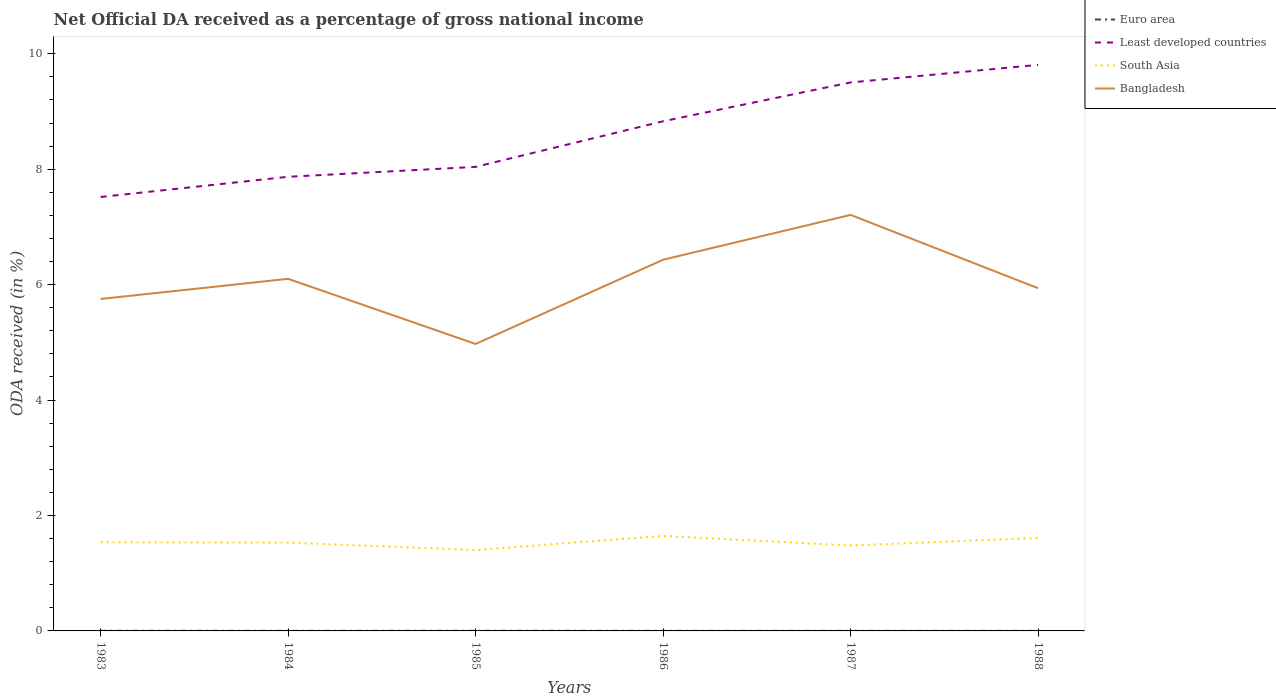How many different coloured lines are there?
Your answer should be very brief. 4. Across all years, what is the maximum net official DA received in Bangladesh?
Offer a very short reply. 4.97. What is the total net official DA received in South Asia in the graph?
Give a very brief answer. -0.07. What is the difference between the highest and the second highest net official DA received in Euro area?
Offer a terse response. 0. What is the difference between the highest and the lowest net official DA received in Bangladesh?
Make the answer very short. 3. Is the net official DA received in Bangladesh strictly greater than the net official DA received in Least developed countries over the years?
Your answer should be very brief. Yes. Are the values on the major ticks of Y-axis written in scientific E-notation?
Give a very brief answer. No. Does the graph contain grids?
Your answer should be very brief. No. Where does the legend appear in the graph?
Give a very brief answer. Top right. How many legend labels are there?
Offer a terse response. 4. How are the legend labels stacked?
Give a very brief answer. Vertical. What is the title of the graph?
Offer a very short reply. Net Official DA received as a percentage of gross national income. What is the label or title of the Y-axis?
Keep it short and to the point. ODA received (in %). What is the ODA received (in %) in Euro area in 1983?
Keep it short and to the point. 0. What is the ODA received (in %) of Least developed countries in 1983?
Your answer should be compact. 7.52. What is the ODA received (in %) of South Asia in 1983?
Make the answer very short. 1.54. What is the ODA received (in %) in Bangladesh in 1983?
Your answer should be compact. 5.75. What is the ODA received (in %) in Euro area in 1984?
Offer a terse response. 0. What is the ODA received (in %) in Least developed countries in 1984?
Make the answer very short. 7.87. What is the ODA received (in %) in South Asia in 1984?
Make the answer very short. 1.53. What is the ODA received (in %) in Bangladesh in 1984?
Provide a succinct answer. 6.1. What is the ODA received (in %) in Euro area in 1985?
Your response must be concise. 0. What is the ODA received (in %) in Least developed countries in 1985?
Keep it short and to the point. 8.04. What is the ODA received (in %) in South Asia in 1985?
Offer a terse response. 1.4. What is the ODA received (in %) of Bangladesh in 1985?
Give a very brief answer. 4.97. What is the ODA received (in %) in Euro area in 1986?
Provide a short and direct response. 0. What is the ODA received (in %) in Least developed countries in 1986?
Offer a very short reply. 8.83. What is the ODA received (in %) in South Asia in 1986?
Make the answer very short. 1.65. What is the ODA received (in %) in Bangladesh in 1986?
Your answer should be very brief. 6.43. What is the ODA received (in %) in Euro area in 1987?
Provide a short and direct response. 0. What is the ODA received (in %) in Least developed countries in 1987?
Provide a succinct answer. 9.5. What is the ODA received (in %) in South Asia in 1987?
Keep it short and to the point. 1.48. What is the ODA received (in %) of Bangladesh in 1987?
Ensure brevity in your answer.  7.21. What is the ODA received (in %) in Euro area in 1988?
Keep it short and to the point. 0. What is the ODA received (in %) of Least developed countries in 1988?
Ensure brevity in your answer.  9.81. What is the ODA received (in %) in South Asia in 1988?
Offer a terse response. 1.61. What is the ODA received (in %) of Bangladesh in 1988?
Keep it short and to the point. 5.94. Across all years, what is the maximum ODA received (in %) in Euro area?
Provide a succinct answer. 0. Across all years, what is the maximum ODA received (in %) of Least developed countries?
Provide a succinct answer. 9.81. Across all years, what is the maximum ODA received (in %) of South Asia?
Provide a succinct answer. 1.65. Across all years, what is the maximum ODA received (in %) in Bangladesh?
Provide a succinct answer. 7.21. Across all years, what is the minimum ODA received (in %) in Euro area?
Make the answer very short. 0. Across all years, what is the minimum ODA received (in %) of Least developed countries?
Your answer should be compact. 7.52. Across all years, what is the minimum ODA received (in %) in South Asia?
Your answer should be compact. 1.4. Across all years, what is the minimum ODA received (in %) in Bangladesh?
Keep it short and to the point. 4.97. What is the total ODA received (in %) of Euro area in the graph?
Offer a very short reply. 0.01. What is the total ODA received (in %) of Least developed countries in the graph?
Keep it short and to the point. 51.57. What is the total ODA received (in %) of South Asia in the graph?
Make the answer very short. 9.21. What is the total ODA received (in %) in Bangladesh in the graph?
Provide a short and direct response. 36.4. What is the difference between the ODA received (in %) in Euro area in 1983 and that in 1984?
Your answer should be compact. 0. What is the difference between the ODA received (in %) in Least developed countries in 1983 and that in 1984?
Your answer should be compact. -0.35. What is the difference between the ODA received (in %) in South Asia in 1983 and that in 1984?
Make the answer very short. 0.01. What is the difference between the ODA received (in %) of Bangladesh in 1983 and that in 1984?
Offer a very short reply. -0.35. What is the difference between the ODA received (in %) of Least developed countries in 1983 and that in 1985?
Offer a very short reply. -0.52. What is the difference between the ODA received (in %) in South Asia in 1983 and that in 1985?
Keep it short and to the point. 0.14. What is the difference between the ODA received (in %) of Bangladesh in 1983 and that in 1985?
Give a very brief answer. 0.78. What is the difference between the ODA received (in %) in Euro area in 1983 and that in 1986?
Ensure brevity in your answer.  0. What is the difference between the ODA received (in %) of Least developed countries in 1983 and that in 1986?
Ensure brevity in your answer.  -1.31. What is the difference between the ODA received (in %) of South Asia in 1983 and that in 1986?
Make the answer very short. -0.11. What is the difference between the ODA received (in %) in Bangladesh in 1983 and that in 1986?
Your answer should be compact. -0.68. What is the difference between the ODA received (in %) in Euro area in 1983 and that in 1987?
Ensure brevity in your answer.  0. What is the difference between the ODA received (in %) of Least developed countries in 1983 and that in 1987?
Your answer should be very brief. -1.99. What is the difference between the ODA received (in %) in South Asia in 1983 and that in 1987?
Offer a terse response. 0.06. What is the difference between the ODA received (in %) of Bangladesh in 1983 and that in 1987?
Offer a terse response. -1.46. What is the difference between the ODA received (in %) of Euro area in 1983 and that in 1988?
Your answer should be very brief. 0. What is the difference between the ODA received (in %) of Least developed countries in 1983 and that in 1988?
Make the answer very short. -2.29. What is the difference between the ODA received (in %) in South Asia in 1983 and that in 1988?
Offer a terse response. -0.07. What is the difference between the ODA received (in %) in Bangladesh in 1983 and that in 1988?
Offer a terse response. -0.19. What is the difference between the ODA received (in %) in Euro area in 1984 and that in 1985?
Your answer should be compact. -0. What is the difference between the ODA received (in %) of Least developed countries in 1984 and that in 1985?
Ensure brevity in your answer.  -0.17. What is the difference between the ODA received (in %) of South Asia in 1984 and that in 1985?
Provide a succinct answer. 0.13. What is the difference between the ODA received (in %) of Bangladesh in 1984 and that in 1985?
Your answer should be compact. 1.13. What is the difference between the ODA received (in %) of Euro area in 1984 and that in 1986?
Provide a succinct answer. -0. What is the difference between the ODA received (in %) in Least developed countries in 1984 and that in 1986?
Your answer should be compact. -0.96. What is the difference between the ODA received (in %) of South Asia in 1984 and that in 1986?
Give a very brief answer. -0.11. What is the difference between the ODA received (in %) of Bangladesh in 1984 and that in 1986?
Provide a short and direct response. -0.33. What is the difference between the ODA received (in %) in Least developed countries in 1984 and that in 1987?
Offer a terse response. -1.64. What is the difference between the ODA received (in %) in South Asia in 1984 and that in 1987?
Your response must be concise. 0.05. What is the difference between the ODA received (in %) in Bangladesh in 1984 and that in 1987?
Make the answer very short. -1.11. What is the difference between the ODA received (in %) of Least developed countries in 1984 and that in 1988?
Your response must be concise. -1.94. What is the difference between the ODA received (in %) of South Asia in 1984 and that in 1988?
Offer a terse response. -0.08. What is the difference between the ODA received (in %) of Bangladesh in 1984 and that in 1988?
Provide a short and direct response. 0.16. What is the difference between the ODA received (in %) in Euro area in 1985 and that in 1986?
Your response must be concise. 0. What is the difference between the ODA received (in %) of Least developed countries in 1985 and that in 1986?
Give a very brief answer. -0.79. What is the difference between the ODA received (in %) of South Asia in 1985 and that in 1986?
Offer a terse response. -0.24. What is the difference between the ODA received (in %) in Bangladesh in 1985 and that in 1986?
Make the answer very short. -1.46. What is the difference between the ODA received (in %) of Euro area in 1985 and that in 1987?
Your answer should be compact. 0. What is the difference between the ODA received (in %) of Least developed countries in 1985 and that in 1987?
Keep it short and to the point. -1.46. What is the difference between the ODA received (in %) of South Asia in 1985 and that in 1987?
Ensure brevity in your answer.  -0.08. What is the difference between the ODA received (in %) in Bangladesh in 1985 and that in 1987?
Keep it short and to the point. -2.24. What is the difference between the ODA received (in %) of Euro area in 1985 and that in 1988?
Your answer should be very brief. 0. What is the difference between the ODA received (in %) in Least developed countries in 1985 and that in 1988?
Keep it short and to the point. -1.77. What is the difference between the ODA received (in %) of South Asia in 1985 and that in 1988?
Offer a terse response. -0.21. What is the difference between the ODA received (in %) in Bangladesh in 1985 and that in 1988?
Offer a very short reply. -0.97. What is the difference between the ODA received (in %) in Least developed countries in 1986 and that in 1987?
Make the answer very short. -0.67. What is the difference between the ODA received (in %) in South Asia in 1986 and that in 1987?
Your answer should be very brief. 0.17. What is the difference between the ODA received (in %) in Bangladesh in 1986 and that in 1987?
Ensure brevity in your answer.  -0.78. What is the difference between the ODA received (in %) of Euro area in 1986 and that in 1988?
Ensure brevity in your answer.  0. What is the difference between the ODA received (in %) in Least developed countries in 1986 and that in 1988?
Give a very brief answer. -0.98. What is the difference between the ODA received (in %) of South Asia in 1986 and that in 1988?
Ensure brevity in your answer.  0.03. What is the difference between the ODA received (in %) of Bangladesh in 1986 and that in 1988?
Give a very brief answer. 0.49. What is the difference between the ODA received (in %) in Euro area in 1987 and that in 1988?
Give a very brief answer. 0. What is the difference between the ODA received (in %) in Least developed countries in 1987 and that in 1988?
Offer a very short reply. -0.3. What is the difference between the ODA received (in %) in South Asia in 1987 and that in 1988?
Your answer should be compact. -0.13. What is the difference between the ODA received (in %) in Bangladesh in 1987 and that in 1988?
Make the answer very short. 1.27. What is the difference between the ODA received (in %) in Euro area in 1983 and the ODA received (in %) in Least developed countries in 1984?
Ensure brevity in your answer.  -7.87. What is the difference between the ODA received (in %) of Euro area in 1983 and the ODA received (in %) of South Asia in 1984?
Your answer should be very brief. -1.53. What is the difference between the ODA received (in %) of Euro area in 1983 and the ODA received (in %) of Bangladesh in 1984?
Your answer should be compact. -6.1. What is the difference between the ODA received (in %) of Least developed countries in 1983 and the ODA received (in %) of South Asia in 1984?
Provide a short and direct response. 5.99. What is the difference between the ODA received (in %) of Least developed countries in 1983 and the ODA received (in %) of Bangladesh in 1984?
Offer a very short reply. 1.42. What is the difference between the ODA received (in %) in South Asia in 1983 and the ODA received (in %) in Bangladesh in 1984?
Offer a very short reply. -4.56. What is the difference between the ODA received (in %) of Euro area in 1983 and the ODA received (in %) of Least developed countries in 1985?
Provide a succinct answer. -8.04. What is the difference between the ODA received (in %) in Euro area in 1983 and the ODA received (in %) in South Asia in 1985?
Your response must be concise. -1.4. What is the difference between the ODA received (in %) of Euro area in 1983 and the ODA received (in %) of Bangladesh in 1985?
Give a very brief answer. -4.97. What is the difference between the ODA received (in %) in Least developed countries in 1983 and the ODA received (in %) in South Asia in 1985?
Provide a short and direct response. 6.12. What is the difference between the ODA received (in %) of Least developed countries in 1983 and the ODA received (in %) of Bangladesh in 1985?
Your answer should be compact. 2.55. What is the difference between the ODA received (in %) in South Asia in 1983 and the ODA received (in %) in Bangladesh in 1985?
Offer a very short reply. -3.44. What is the difference between the ODA received (in %) of Euro area in 1983 and the ODA received (in %) of Least developed countries in 1986?
Make the answer very short. -8.83. What is the difference between the ODA received (in %) of Euro area in 1983 and the ODA received (in %) of South Asia in 1986?
Give a very brief answer. -1.64. What is the difference between the ODA received (in %) in Euro area in 1983 and the ODA received (in %) in Bangladesh in 1986?
Ensure brevity in your answer.  -6.43. What is the difference between the ODA received (in %) of Least developed countries in 1983 and the ODA received (in %) of South Asia in 1986?
Keep it short and to the point. 5.87. What is the difference between the ODA received (in %) of Least developed countries in 1983 and the ODA received (in %) of Bangladesh in 1986?
Your response must be concise. 1.09. What is the difference between the ODA received (in %) of South Asia in 1983 and the ODA received (in %) of Bangladesh in 1986?
Offer a very short reply. -4.9. What is the difference between the ODA received (in %) of Euro area in 1983 and the ODA received (in %) of Least developed countries in 1987?
Offer a very short reply. -9.5. What is the difference between the ODA received (in %) of Euro area in 1983 and the ODA received (in %) of South Asia in 1987?
Offer a very short reply. -1.48. What is the difference between the ODA received (in %) of Euro area in 1983 and the ODA received (in %) of Bangladesh in 1987?
Provide a succinct answer. -7.21. What is the difference between the ODA received (in %) of Least developed countries in 1983 and the ODA received (in %) of South Asia in 1987?
Keep it short and to the point. 6.04. What is the difference between the ODA received (in %) of Least developed countries in 1983 and the ODA received (in %) of Bangladesh in 1987?
Keep it short and to the point. 0.31. What is the difference between the ODA received (in %) in South Asia in 1983 and the ODA received (in %) in Bangladesh in 1987?
Your response must be concise. -5.67. What is the difference between the ODA received (in %) in Euro area in 1983 and the ODA received (in %) in Least developed countries in 1988?
Keep it short and to the point. -9.81. What is the difference between the ODA received (in %) of Euro area in 1983 and the ODA received (in %) of South Asia in 1988?
Provide a short and direct response. -1.61. What is the difference between the ODA received (in %) in Euro area in 1983 and the ODA received (in %) in Bangladesh in 1988?
Offer a very short reply. -5.94. What is the difference between the ODA received (in %) of Least developed countries in 1983 and the ODA received (in %) of South Asia in 1988?
Your answer should be very brief. 5.91. What is the difference between the ODA received (in %) of Least developed countries in 1983 and the ODA received (in %) of Bangladesh in 1988?
Ensure brevity in your answer.  1.58. What is the difference between the ODA received (in %) of South Asia in 1983 and the ODA received (in %) of Bangladesh in 1988?
Provide a short and direct response. -4.4. What is the difference between the ODA received (in %) of Euro area in 1984 and the ODA received (in %) of Least developed countries in 1985?
Provide a succinct answer. -8.04. What is the difference between the ODA received (in %) of Euro area in 1984 and the ODA received (in %) of South Asia in 1985?
Your response must be concise. -1.4. What is the difference between the ODA received (in %) of Euro area in 1984 and the ODA received (in %) of Bangladesh in 1985?
Provide a short and direct response. -4.97. What is the difference between the ODA received (in %) in Least developed countries in 1984 and the ODA received (in %) in South Asia in 1985?
Your answer should be compact. 6.47. What is the difference between the ODA received (in %) of Least developed countries in 1984 and the ODA received (in %) of Bangladesh in 1985?
Offer a terse response. 2.9. What is the difference between the ODA received (in %) of South Asia in 1984 and the ODA received (in %) of Bangladesh in 1985?
Ensure brevity in your answer.  -3.44. What is the difference between the ODA received (in %) in Euro area in 1984 and the ODA received (in %) in Least developed countries in 1986?
Provide a succinct answer. -8.83. What is the difference between the ODA received (in %) in Euro area in 1984 and the ODA received (in %) in South Asia in 1986?
Offer a very short reply. -1.65. What is the difference between the ODA received (in %) of Euro area in 1984 and the ODA received (in %) of Bangladesh in 1986?
Your answer should be compact. -6.43. What is the difference between the ODA received (in %) of Least developed countries in 1984 and the ODA received (in %) of South Asia in 1986?
Provide a short and direct response. 6.22. What is the difference between the ODA received (in %) of Least developed countries in 1984 and the ODA received (in %) of Bangladesh in 1986?
Provide a succinct answer. 1.44. What is the difference between the ODA received (in %) of South Asia in 1984 and the ODA received (in %) of Bangladesh in 1986?
Your answer should be compact. -4.9. What is the difference between the ODA received (in %) of Euro area in 1984 and the ODA received (in %) of Least developed countries in 1987?
Offer a terse response. -9.5. What is the difference between the ODA received (in %) in Euro area in 1984 and the ODA received (in %) in South Asia in 1987?
Your answer should be compact. -1.48. What is the difference between the ODA received (in %) of Euro area in 1984 and the ODA received (in %) of Bangladesh in 1987?
Provide a short and direct response. -7.21. What is the difference between the ODA received (in %) of Least developed countries in 1984 and the ODA received (in %) of South Asia in 1987?
Offer a terse response. 6.39. What is the difference between the ODA received (in %) in Least developed countries in 1984 and the ODA received (in %) in Bangladesh in 1987?
Provide a short and direct response. 0.66. What is the difference between the ODA received (in %) of South Asia in 1984 and the ODA received (in %) of Bangladesh in 1987?
Give a very brief answer. -5.68. What is the difference between the ODA received (in %) of Euro area in 1984 and the ODA received (in %) of Least developed countries in 1988?
Make the answer very short. -9.81. What is the difference between the ODA received (in %) in Euro area in 1984 and the ODA received (in %) in South Asia in 1988?
Give a very brief answer. -1.61. What is the difference between the ODA received (in %) of Euro area in 1984 and the ODA received (in %) of Bangladesh in 1988?
Offer a terse response. -5.94. What is the difference between the ODA received (in %) in Least developed countries in 1984 and the ODA received (in %) in South Asia in 1988?
Offer a very short reply. 6.26. What is the difference between the ODA received (in %) of Least developed countries in 1984 and the ODA received (in %) of Bangladesh in 1988?
Your answer should be compact. 1.93. What is the difference between the ODA received (in %) in South Asia in 1984 and the ODA received (in %) in Bangladesh in 1988?
Give a very brief answer. -4.41. What is the difference between the ODA received (in %) of Euro area in 1985 and the ODA received (in %) of Least developed countries in 1986?
Your answer should be very brief. -8.83. What is the difference between the ODA received (in %) of Euro area in 1985 and the ODA received (in %) of South Asia in 1986?
Your answer should be very brief. -1.64. What is the difference between the ODA received (in %) in Euro area in 1985 and the ODA received (in %) in Bangladesh in 1986?
Offer a very short reply. -6.43. What is the difference between the ODA received (in %) in Least developed countries in 1985 and the ODA received (in %) in South Asia in 1986?
Give a very brief answer. 6.39. What is the difference between the ODA received (in %) in Least developed countries in 1985 and the ODA received (in %) in Bangladesh in 1986?
Offer a very short reply. 1.61. What is the difference between the ODA received (in %) of South Asia in 1985 and the ODA received (in %) of Bangladesh in 1986?
Keep it short and to the point. -5.03. What is the difference between the ODA received (in %) in Euro area in 1985 and the ODA received (in %) in Least developed countries in 1987?
Your answer should be compact. -9.5. What is the difference between the ODA received (in %) of Euro area in 1985 and the ODA received (in %) of South Asia in 1987?
Offer a terse response. -1.48. What is the difference between the ODA received (in %) of Euro area in 1985 and the ODA received (in %) of Bangladesh in 1987?
Keep it short and to the point. -7.21. What is the difference between the ODA received (in %) in Least developed countries in 1985 and the ODA received (in %) in South Asia in 1987?
Give a very brief answer. 6.56. What is the difference between the ODA received (in %) in Least developed countries in 1985 and the ODA received (in %) in Bangladesh in 1987?
Your answer should be compact. 0.83. What is the difference between the ODA received (in %) of South Asia in 1985 and the ODA received (in %) of Bangladesh in 1987?
Give a very brief answer. -5.81. What is the difference between the ODA received (in %) in Euro area in 1985 and the ODA received (in %) in Least developed countries in 1988?
Keep it short and to the point. -9.81. What is the difference between the ODA received (in %) in Euro area in 1985 and the ODA received (in %) in South Asia in 1988?
Make the answer very short. -1.61. What is the difference between the ODA received (in %) in Euro area in 1985 and the ODA received (in %) in Bangladesh in 1988?
Offer a very short reply. -5.94. What is the difference between the ODA received (in %) in Least developed countries in 1985 and the ODA received (in %) in South Asia in 1988?
Provide a succinct answer. 6.43. What is the difference between the ODA received (in %) in Least developed countries in 1985 and the ODA received (in %) in Bangladesh in 1988?
Your answer should be very brief. 2.1. What is the difference between the ODA received (in %) in South Asia in 1985 and the ODA received (in %) in Bangladesh in 1988?
Keep it short and to the point. -4.54. What is the difference between the ODA received (in %) of Euro area in 1986 and the ODA received (in %) of Least developed countries in 1987?
Your answer should be very brief. -9.5. What is the difference between the ODA received (in %) of Euro area in 1986 and the ODA received (in %) of South Asia in 1987?
Give a very brief answer. -1.48. What is the difference between the ODA received (in %) of Euro area in 1986 and the ODA received (in %) of Bangladesh in 1987?
Give a very brief answer. -7.21. What is the difference between the ODA received (in %) in Least developed countries in 1986 and the ODA received (in %) in South Asia in 1987?
Your answer should be compact. 7.35. What is the difference between the ODA received (in %) of Least developed countries in 1986 and the ODA received (in %) of Bangladesh in 1987?
Offer a very short reply. 1.62. What is the difference between the ODA received (in %) in South Asia in 1986 and the ODA received (in %) in Bangladesh in 1987?
Your answer should be compact. -5.56. What is the difference between the ODA received (in %) of Euro area in 1986 and the ODA received (in %) of Least developed countries in 1988?
Ensure brevity in your answer.  -9.81. What is the difference between the ODA received (in %) of Euro area in 1986 and the ODA received (in %) of South Asia in 1988?
Ensure brevity in your answer.  -1.61. What is the difference between the ODA received (in %) in Euro area in 1986 and the ODA received (in %) in Bangladesh in 1988?
Offer a terse response. -5.94. What is the difference between the ODA received (in %) in Least developed countries in 1986 and the ODA received (in %) in South Asia in 1988?
Your answer should be very brief. 7.22. What is the difference between the ODA received (in %) of Least developed countries in 1986 and the ODA received (in %) of Bangladesh in 1988?
Offer a very short reply. 2.89. What is the difference between the ODA received (in %) in South Asia in 1986 and the ODA received (in %) in Bangladesh in 1988?
Provide a succinct answer. -4.29. What is the difference between the ODA received (in %) of Euro area in 1987 and the ODA received (in %) of Least developed countries in 1988?
Offer a terse response. -9.81. What is the difference between the ODA received (in %) of Euro area in 1987 and the ODA received (in %) of South Asia in 1988?
Offer a terse response. -1.61. What is the difference between the ODA received (in %) of Euro area in 1987 and the ODA received (in %) of Bangladesh in 1988?
Provide a short and direct response. -5.94. What is the difference between the ODA received (in %) of Least developed countries in 1987 and the ODA received (in %) of South Asia in 1988?
Give a very brief answer. 7.89. What is the difference between the ODA received (in %) of Least developed countries in 1987 and the ODA received (in %) of Bangladesh in 1988?
Offer a terse response. 3.57. What is the difference between the ODA received (in %) of South Asia in 1987 and the ODA received (in %) of Bangladesh in 1988?
Your response must be concise. -4.46. What is the average ODA received (in %) of Euro area per year?
Your answer should be compact. 0. What is the average ODA received (in %) in Least developed countries per year?
Make the answer very short. 8.6. What is the average ODA received (in %) in South Asia per year?
Make the answer very short. 1.53. What is the average ODA received (in %) in Bangladesh per year?
Ensure brevity in your answer.  6.07. In the year 1983, what is the difference between the ODA received (in %) of Euro area and ODA received (in %) of Least developed countries?
Offer a very short reply. -7.52. In the year 1983, what is the difference between the ODA received (in %) in Euro area and ODA received (in %) in South Asia?
Keep it short and to the point. -1.53. In the year 1983, what is the difference between the ODA received (in %) of Euro area and ODA received (in %) of Bangladesh?
Make the answer very short. -5.75. In the year 1983, what is the difference between the ODA received (in %) in Least developed countries and ODA received (in %) in South Asia?
Your answer should be very brief. 5.98. In the year 1983, what is the difference between the ODA received (in %) of Least developed countries and ODA received (in %) of Bangladesh?
Your response must be concise. 1.77. In the year 1983, what is the difference between the ODA received (in %) in South Asia and ODA received (in %) in Bangladesh?
Your response must be concise. -4.22. In the year 1984, what is the difference between the ODA received (in %) in Euro area and ODA received (in %) in Least developed countries?
Your response must be concise. -7.87. In the year 1984, what is the difference between the ODA received (in %) in Euro area and ODA received (in %) in South Asia?
Offer a very short reply. -1.53. In the year 1984, what is the difference between the ODA received (in %) of Euro area and ODA received (in %) of Bangladesh?
Your answer should be very brief. -6.1. In the year 1984, what is the difference between the ODA received (in %) of Least developed countries and ODA received (in %) of South Asia?
Provide a short and direct response. 6.34. In the year 1984, what is the difference between the ODA received (in %) of Least developed countries and ODA received (in %) of Bangladesh?
Offer a very short reply. 1.77. In the year 1984, what is the difference between the ODA received (in %) of South Asia and ODA received (in %) of Bangladesh?
Give a very brief answer. -4.57. In the year 1985, what is the difference between the ODA received (in %) in Euro area and ODA received (in %) in Least developed countries?
Offer a very short reply. -8.04. In the year 1985, what is the difference between the ODA received (in %) of Euro area and ODA received (in %) of South Asia?
Your response must be concise. -1.4. In the year 1985, what is the difference between the ODA received (in %) in Euro area and ODA received (in %) in Bangladesh?
Keep it short and to the point. -4.97. In the year 1985, what is the difference between the ODA received (in %) of Least developed countries and ODA received (in %) of South Asia?
Give a very brief answer. 6.64. In the year 1985, what is the difference between the ODA received (in %) of Least developed countries and ODA received (in %) of Bangladesh?
Offer a terse response. 3.07. In the year 1985, what is the difference between the ODA received (in %) of South Asia and ODA received (in %) of Bangladesh?
Provide a succinct answer. -3.57. In the year 1986, what is the difference between the ODA received (in %) in Euro area and ODA received (in %) in Least developed countries?
Give a very brief answer. -8.83. In the year 1986, what is the difference between the ODA received (in %) in Euro area and ODA received (in %) in South Asia?
Give a very brief answer. -1.65. In the year 1986, what is the difference between the ODA received (in %) of Euro area and ODA received (in %) of Bangladesh?
Offer a terse response. -6.43. In the year 1986, what is the difference between the ODA received (in %) of Least developed countries and ODA received (in %) of South Asia?
Make the answer very short. 7.18. In the year 1986, what is the difference between the ODA received (in %) in Least developed countries and ODA received (in %) in Bangladesh?
Your answer should be compact. 2.4. In the year 1986, what is the difference between the ODA received (in %) of South Asia and ODA received (in %) of Bangladesh?
Give a very brief answer. -4.79. In the year 1987, what is the difference between the ODA received (in %) of Euro area and ODA received (in %) of Least developed countries?
Ensure brevity in your answer.  -9.5. In the year 1987, what is the difference between the ODA received (in %) in Euro area and ODA received (in %) in South Asia?
Your answer should be compact. -1.48. In the year 1987, what is the difference between the ODA received (in %) of Euro area and ODA received (in %) of Bangladesh?
Give a very brief answer. -7.21. In the year 1987, what is the difference between the ODA received (in %) in Least developed countries and ODA received (in %) in South Asia?
Your answer should be very brief. 8.02. In the year 1987, what is the difference between the ODA received (in %) of Least developed countries and ODA received (in %) of Bangladesh?
Your response must be concise. 2.3. In the year 1987, what is the difference between the ODA received (in %) in South Asia and ODA received (in %) in Bangladesh?
Provide a short and direct response. -5.73. In the year 1988, what is the difference between the ODA received (in %) in Euro area and ODA received (in %) in Least developed countries?
Make the answer very short. -9.81. In the year 1988, what is the difference between the ODA received (in %) of Euro area and ODA received (in %) of South Asia?
Your answer should be very brief. -1.61. In the year 1988, what is the difference between the ODA received (in %) of Euro area and ODA received (in %) of Bangladesh?
Make the answer very short. -5.94. In the year 1988, what is the difference between the ODA received (in %) of Least developed countries and ODA received (in %) of South Asia?
Ensure brevity in your answer.  8.2. In the year 1988, what is the difference between the ODA received (in %) in Least developed countries and ODA received (in %) in Bangladesh?
Make the answer very short. 3.87. In the year 1988, what is the difference between the ODA received (in %) of South Asia and ODA received (in %) of Bangladesh?
Provide a succinct answer. -4.33. What is the ratio of the ODA received (in %) in Euro area in 1983 to that in 1984?
Provide a succinct answer. 2.13. What is the ratio of the ODA received (in %) of Least developed countries in 1983 to that in 1984?
Your response must be concise. 0.96. What is the ratio of the ODA received (in %) in Bangladesh in 1983 to that in 1984?
Keep it short and to the point. 0.94. What is the ratio of the ODA received (in %) of Euro area in 1983 to that in 1985?
Offer a terse response. 1.12. What is the ratio of the ODA received (in %) in Least developed countries in 1983 to that in 1985?
Ensure brevity in your answer.  0.94. What is the ratio of the ODA received (in %) of South Asia in 1983 to that in 1985?
Provide a succinct answer. 1.1. What is the ratio of the ODA received (in %) in Bangladesh in 1983 to that in 1985?
Provide a short and direct response. 1.16. What is the ratio of the ODA received (in %) of Euro area in 1983 to that in 1986?
Offer a very short reply. 2.07. What is the ratio of the ODA received (in %) of Least developed countries in 1983 to that in 1986?
Make the answer very short. 0.85. What is the ratio of the ODA received (in %) in South Asia in 1983 to that in 1986?
Provide a short and direct response. 0.93. What is the ratio of the ODA received (in %) in Bangladesh in 1983 to that in 1986?
Your response must be concise. 0.89. What is the ratio of the ODA received (in %) of Euro area in 1983 to that in 1987?
Your answer should be compact. 2.69. What is the ratio of the ODA received (in %) of Least developed countries in 1983 to that in 1987?
Keep it short and to the point. 0.79. What is the ratio of the ODA received (in %) of South Asia in 1983 to that in 1987?
Provide a succinct answer. 1.04. What is the ratio of the ODA received (in %) of Bangladesh in 1983 to that in 1987?
Provide a short and direct response. 0.8. What is the ratio of the ODA received (in %) in Euro area in 1983 to that in 1988?
Make the answer very short. 2.86. What is the ratio of the ODA received (in %) in Least developed countries in 1983 to that in 1988?
Ensure brevity in your answer.  0.77. What is the ratio of the ODA received (in %) of South Asia in 1983 to that in 1988?
Offer a terse response. 0.95. What is the ratio of the ODA received (in %) of Bangladesh in 1983 to that in 1988?
Your answer should be compact. 0.97. What is the ratio of the ODA received (in %) in Euro area in 1984 to that in 1985?
Give a very brief answer. 0.53. What is the ratio of the ODA received (in %) in Least developed countries in 1984 to that in 1985?
Provide a succinct answer. 0.98. What is the ratio of the ODA received (in %) in South Asia in 1984 to that in 1985?
Keep it short and to the point. 1.09. What is the ratio of the ODA received (in %) in Bangladesh in 1984 to that in 1985?
Your answer should be compact. 1.23. What is the ratio of the ODA received (in %) in Euro area in 1984 to that in 1986?
Give a very brief answer. 0.97. What is the ratio of the ODA received (in %) in Least developed countries in 1984 to that in 1986?
Offer a very short reply. 0.89. What is the ratio of the ODA received (in %) of South Asia in 1984 to that in 1986?
Your answer should be compact. 0.93. What is the ratio of the ODA received (in %) of Bangladesh in 1984 to that in 1986?
Offer a very short reply. 0.95. What is the ratio of the ODA received (in %) of Euro area in 1984 to that in 1987?
Offer a very short reply. 1.27. What is the ratio of the ODA received (in %) in Least developed countries in 1984 to that in 1987?
Your response must be concise. 0.83. What is the ratio of the ODA received (in %) in South Asia in 1984 to that in 1987?
Give a very brief answer. 1.03. What is the ratio of the ODA received (in %) in Bangladesh in 1984 to that in 1987?
Offer a very short reply. 0.85. What is the ratio of the ODA received (in %) of Euro area in 1984 to that in 1988?
Your answer should be compact. 1.34. What is the ratio of the ODA received (in %) in Least developed countries in 1984 to that in 1988?
Your response must be concise. 0.8. What is the ratio of the ODA received (in %) of South Asia in 1984 to that in 1988?
Give a very brief answer. 0.95. What is the ratio of the ODA received (in %) of Bangladesh in 1984 to that in 1988?
Make the answer very short. 1.03. What is the ratio of the ODA received (in %) of Euro area in 1985 to that in 1986?
Your response must be concise. 1.85. What is the ratio of the ODA received (in %) of Least developed countries in 1985 to that in 1986?
Your response must be concise. 0.91. What is the ratio of the ODA received (in %) of South Asia in 1985 to that in 1986?
Provide a succinct answer. 0.85. What is the ratio of the ODA received (in %) of Bangladesh in 1985 to that in 1986?
Your response must be concise. 0.77. What is the ratio of the ODA received (in %) in Euro area in 1985 to that in 1987?
Your response must be concise. 2.41. What is the ratio of the ODA received (in %) of Least developed countries in 1985 to that in 1987?
Your answer should be very brief. 0.85. What is the ratio of the ODA received (in %) of South Asia in 1985 to that in 1987?
Ensure brevity in your answer.  0.95. What is the ratio of the ODA received (in %) of Bangladesh in 1985 to that in 1987?
Your response must be concise. 0.69. What is the ratio of the ODA received (in %) in Euro area in 1985 to that in 1988?
Ensure brevity in your answer.  2.55. What is the ratio of the ODA received (in %) of Least developed countries in 1985 to that in 1988?
Offer a terse response. 0.82. What is the ratio of the ODA received (in %) in South Asia in 1985 to that in 1988?
Offer a very short reply. 0.87. What is the ratio of the ODA received (in %) of Bangladesh in 1985 to that in 1988?
Your response must be concise. 0.84. What is the ratio of the ODA received (in %) of Euro area in 1986 to that in 1987?
Keep it short and to the point. 1.3. What is the ratio of the ODA received (in %) of Least developed countries in 1986 to that in 1987?
Ensure brevity in your answer.  0.93. What is the ratio of the ODA received (in %) of South Asia in 1986 to that in 1987?
Your response must be concise. 1.11. What is the ratio of the ODA received (in %) in Bangladesh in 1986 to that in 1987?
Provide a succinct answer. 0.89. What is the ratio of the ODA received (in %) of Euro area in 1986 to that in 1988?
Your answer should be very brief. 1.38. What is the ratio of the ODA received (in %) of Least developed countries in 1986 to that in 1988?
Your answer should be compact. 0.9. What is the ratio of the ODA received (in %) in South Asia in 1986 to that in 1988?
Keep it short and to the point. 1.02. What is the ratio of the ODA received (in %) in Bangladesh in 1986 to that in 1988?
Offer a terse response. 1.08. What is the ratio of the ODA received (in %) in Euro area in 1987 to that in 1988?
Give a very brief answer. 1.06. What is the ratio of the ODA received (in %) in Least developed countries in 1987 to that in 1988?
Provide a short and direct response. 0.97. What is the ratio of the ODA received (in %) of South Asia in 1987 to that in 1988?
Your response must be concise. 0.92. What is the ratio of the ODA received (in %) of Bangladesh in 1987 to that in 1988?
Keep it short and to the point. 1.21. What is the difference between the highest and the second highest ODA received (in %) of Least developed countries?
Offer a terse response. 0.3. What is the difference between the highest and the second highest ODA received (in %) of South Asia?
Your response must be concise. 0.03. What is the difference between the highest and the second highest ODA received (in %) in Bangladesh?
Offer a terse response. 0.78. What is the difference between the highest and the lowest ODA received (in %) of Euro area?
Ensure brevity in your answer.  0. What is the difference between the highest and the lowest ODA received (in %) in Least developed countries?
Give a very brief answer. 2.29. What is the difference between the highest and the lowest ODA received (in %) of South Asia?
Your answer should be compact. 0.24. What is the difference between the highest and the lowest ODA received (in %) of Bangladesh?
Provide a short and direct response. 2.24. 